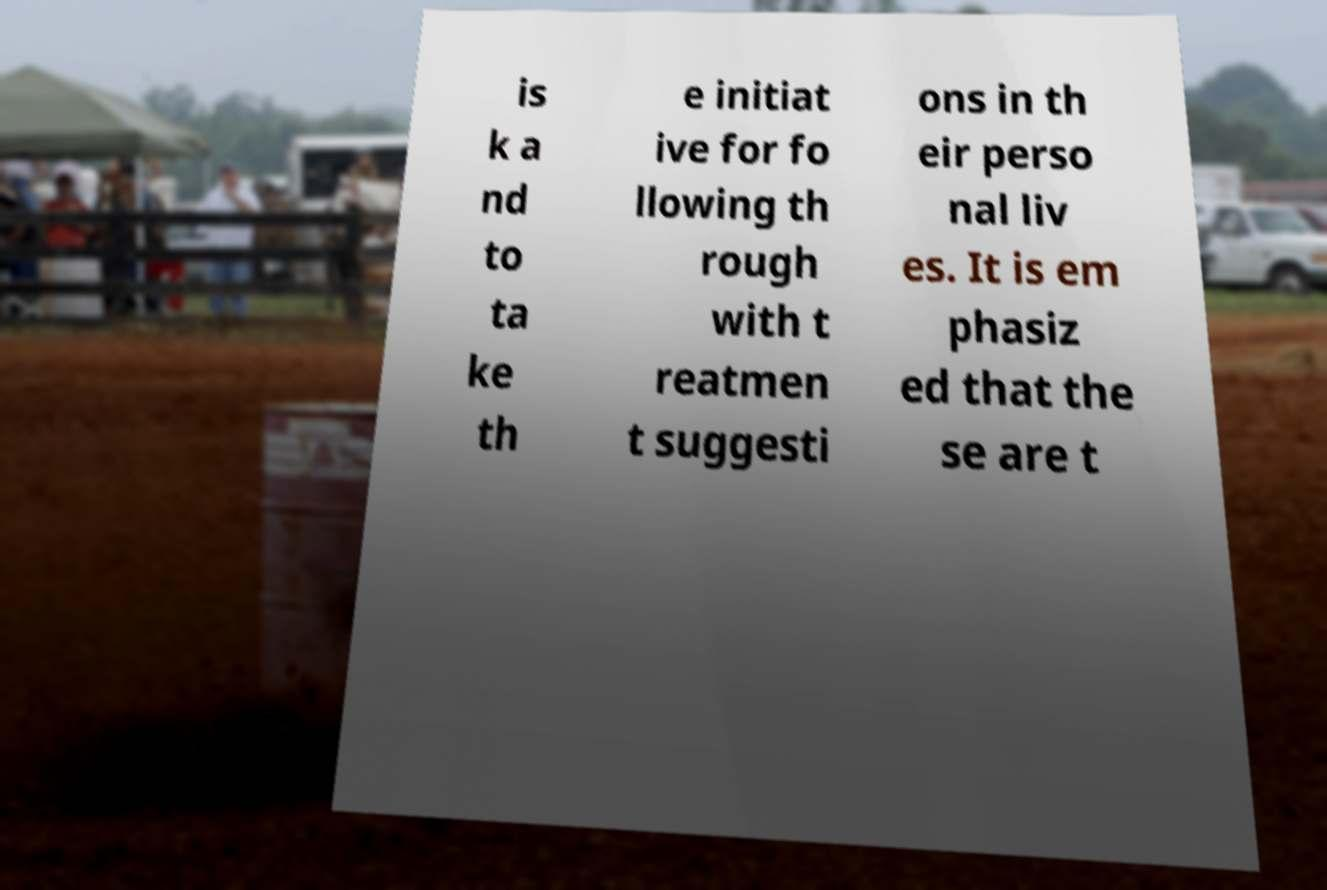What messages or text are displayed in this image? I need them in a readable, typed format. is k a nd to ta ke th e initiat ive for fo llowing th rough with t reatmen t suggesti ons in th eir perso nal liv es. It is em phasiz ed that the se are t 